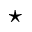<formula> <loc_0><loc_0><loc_500><loc_500>^ { * }</formula> 